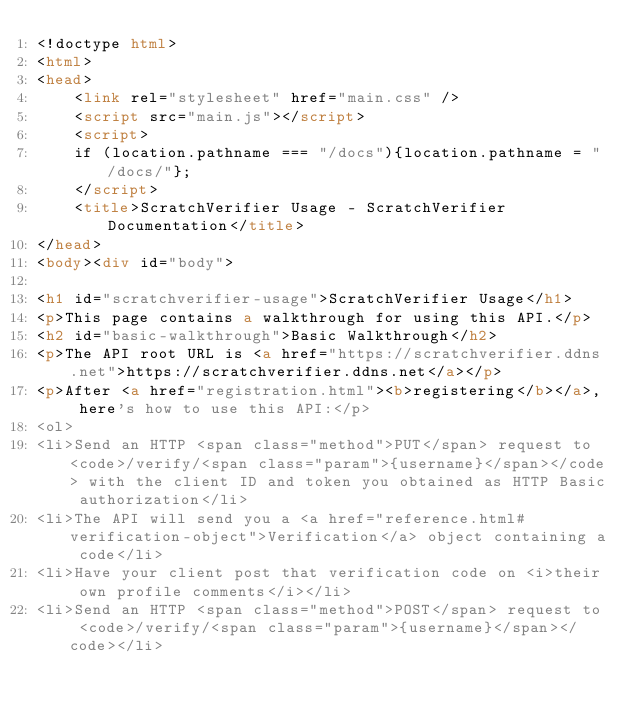Convert code to text. <code><loc_0><loc_0><loc_500><loc_500><_HTML_><!doctype html>
<html>
<head>
    <link rel="stylesheet" href="main.css" />
    <script src="main.js"></script>
    <script>
    if (location.pathname === "/docs"){location.pathname = "/docs/"};
    </script>
    <title>ScratchVerifier Usage - ScratchVerifier Documentation</title>
</head>
<body><div id="body">

<h1 id="scratchverifier-usage">ScratchVerifier Usage</h1>
<p>This page contains a walkthrough for using this API.</p>
<h2 id="basic-walkthrough">Basic Walkthrough</h2>
<p>The API root URL is <a href="https://scratchverifier.ddns.net">https://scratchverifier.ddns.net</a></p>
<p>After <a href="registration.html"><b>registering</b></a>, here's how to use this API:</p>
<ol>
<li>Send an HTTP <span class="method">PUT</span> request to <code>/verify/<span class="param">{username}</span></code> with the client ID and token you obtained as HTTP Basic authorization</li>
<li>The API will send you a <a href="reference.html#verification-object">Verification</a> object containing a code</li>
<li>Have your client post that verification code on <i>their own profile comments</i></li>
<li>Send an HTTP <span class="method">POST</span> request to <code>/verify/<span class="param">{username}</span></code></li></code> 